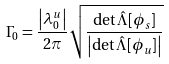<formula> <loc_0><loc_0><loc_500><loc_500>\Gamma _ { 0 } = \frac { \left | \lambda _ { 0 } ^ { u } \right | } { 2 \pi } \sqrt { \frac { \det { \hat { \Lambda } } [ \phi _ { s } ] } { \left | \det { \hat { \Lambda } } [ \phi _ { u } ] \right | } }</formula> 